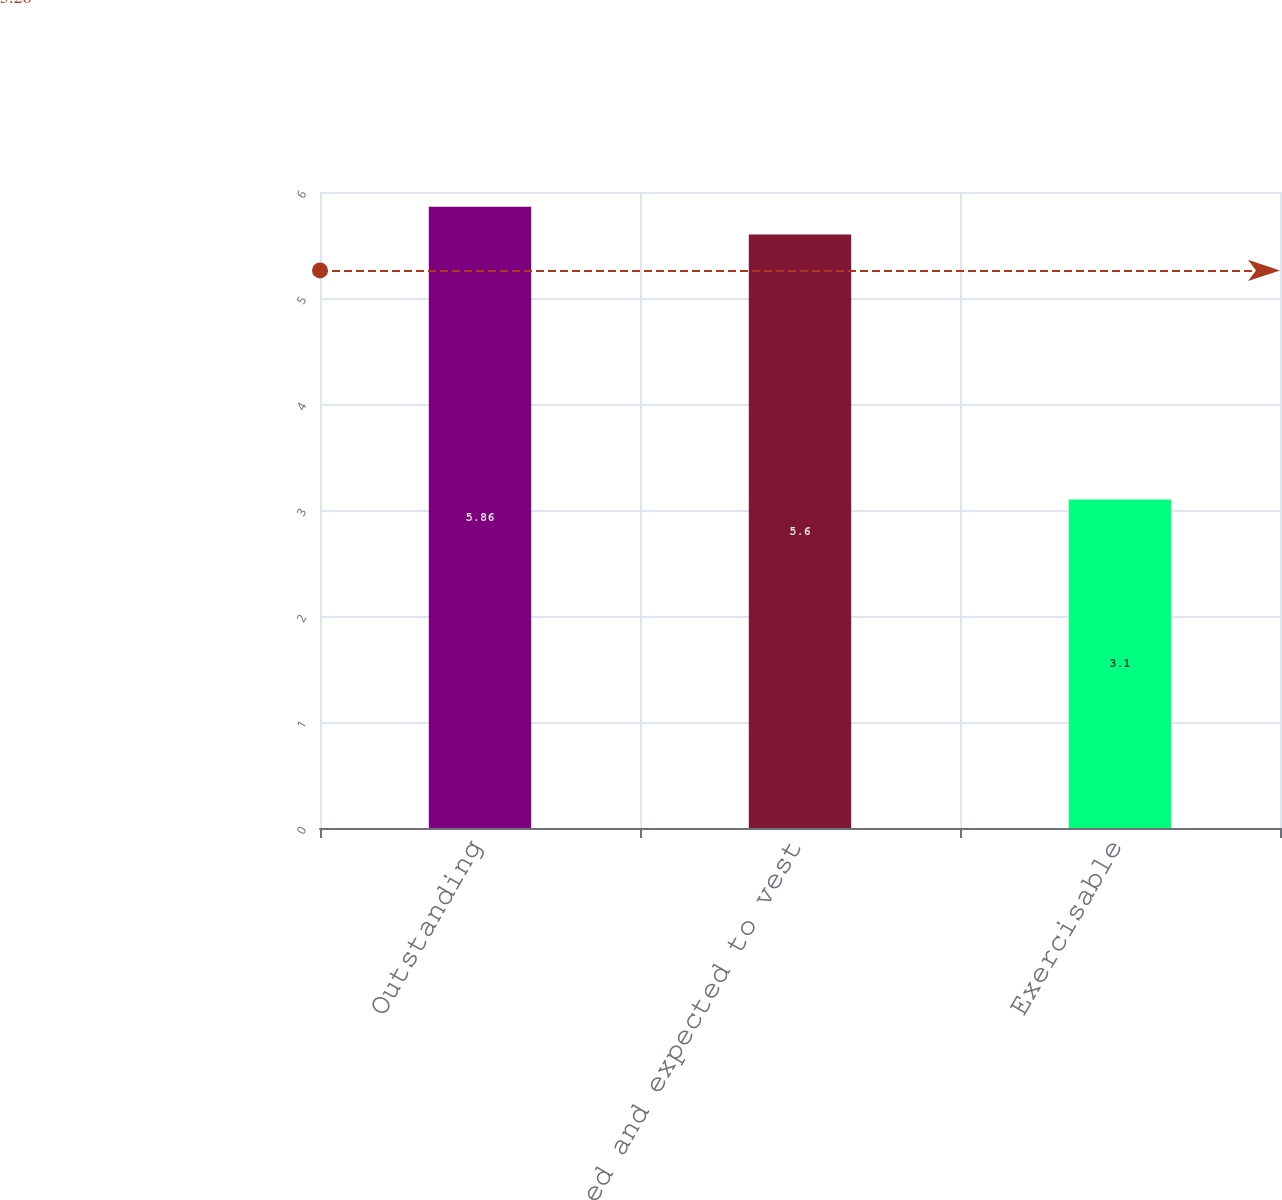Convert chart. <chart><loc_0><loc_0><loc_500><loc_500><bar_chart><fcel>Outstanding<fcel>Vested and expected to vest<fcel>Exercisable<nl><fcel>5.86<fcel>5.6<fcel>3.1<nl></chart> 